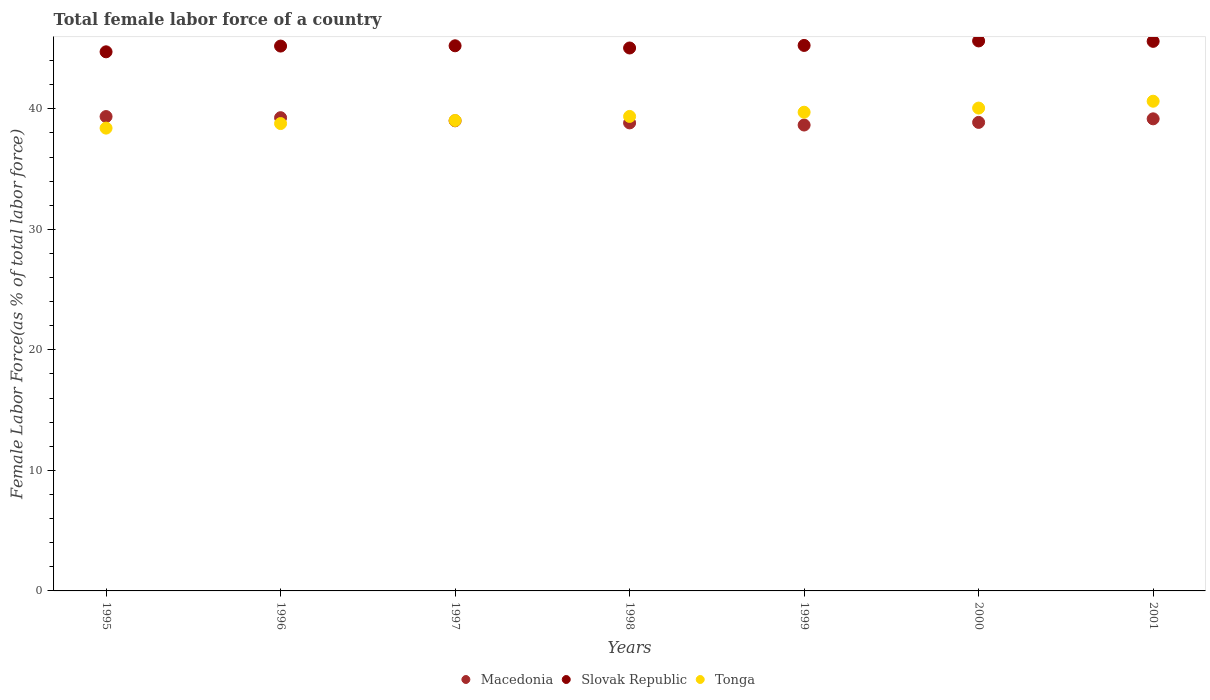How many different coloured dotlines are there?
Your answer should be compact. 3. What is the percentage of female labor force in Slovak Republic in 1997?
Your response must be concise. 45.23. Across all years, what is the maximum percentage of female labor force in Tonga?
Your answer should be very brief. 40.63. Across all years, what is the minimum percentage of female labor force in Slovak Republic?
Your answer should be compact. 44.73. In which year was the percentage of female labor force in Slovak Republic maximum?
Your response must be concise. 2000. What is the total percentage of female labor force in Tonga in the graph?
Your answer should be very brief. 275.99. What is the difference between the percentage of female labor force in Tonga in 1996 and that in 1998?
Make the answer very short. -0.59. What is the difference between the percentage of female labor force in Tonga in 1999 and the percentage of female labor force in Macedonia in 1996?
Your answer should be very brief. 0.45. What is the average percentage of female labor force in Slovak Republic per year?
Ensure brevity in your answer.  45.24. In the year 2001, what is the difference between the percentage of female labor force in Slovak Republic and percentage of female labor force in Tonga?
Your answer should be compact. 4.97. In how many years, is the percentage of female labor force in Tonga greater than 14 %?
Offer a terse response. 7. What is the ratio of the percentage of female labor force in Macedonia in 1995 to that in 1996?
Your answer should be very brief. 1. Is the percentage of female labor force in Tonga in 1996 less than that in 2000?
Your response must be concise. Yes. What is the difference between the highest and the second highest percentage of female labor force in Macedonia?
Make the answer very short. 0.09. What is the difference between the highest and the lowest percentage of female labor force in Slovak Republic?
Your answer should be compact. 0.9. Is it the case that in every year, the sum of the percentage of female labor force in Macedonia and percentage of female labor force in Slovak Republic  is greater than the percentage of female labor force in Tonga?
Ensure brevity in your answer.  Yes. Is the percentage of female labor force in Macedonia strictly greater than the percentage of female labor force in Slovak Republic over the years?
Ensure brevity in your answer.  No. How many dotlines are there?
Your answer should be very brief. 3. How many years are there in the graph?
Keep it short and to the point. 7. What is the difference between two consecutive major ticks on the Y-axis?
Ensure brevity in your answer.  10. Does the graph contain any zero values?
Provide a short and direct response. No. What is the title of the graph?
Give a very brief answer. Total female labor force of a country. Does "China" appear as one of the legend labels in the graph?
Make the answer very short. No. What is the label or title of the X-axis?
Ensure brevity in your answer.  Years. What is the label or title of the Y-axis?
Your response must be concise. Female Labor Force(as % of total labor force). What is the Female Labor Force(as % of total labor force) of Macedonia in 1995?
Provide a short and direct response. 39.36. What is the Female Labor Force(as % of total labor force) in Slovak Republic in 1995?
Your answer should be compact. 44.73. What is the Female Labor Force(as % of total labor force) of Tonga in 1995?
Your answer should be compact. 38.4. What is the Female Labor Force(as % of total labor force) of Macedonia in 1996?
Provide a succinct answer. 39.26. What is the Female Labor Force(as % of total labor force) in Slovak Republic in 1996?
Your response must be concise. 45.21. What is the Female Labor Force(as % of total labor force) in Tonga in 1996?
Ensure brevity in your answer.  38.78. What is the Female Labor Force(as % of total labor force) in Macedonia in 1997?
Offer a terse response. 39.01. What is the Female Labor Force(as % of total labor force) of Slovak Republic in 1997?
Offer a terse response. 45.23. What is the Female Labor Force(as % of total labor force) in Tonga in 1997?
Offer a terse response. 39.03. What is the Female Labor Force(as % of total labor force) in Macedonia in 1998?
Ensure brevity in your answer.  38.83. What is the Female Labor Force(as % of total labor force) in Slovak Republic in 1998?
Offer a very short reply. 45.05. What is the Female Labor Force(as % of total labor force) in Tonga in 1998?
Your answer should be very brief. 39.37. What is the Female Labor Force(as % of total labor force) in Macedonia in 1999?
Your answer should be compact. 38.66. What is the Female Labor Force(as % of total labor force) in Slovak Republic in 1999?
Keep it short and to the point. 45.26. What is the Female Labor Force(as % of total labor force) of Tonga in 1999?
Your answer should be very brief. 39.72. What is the Female Labor Force(as % of total labor force) in Macedonia in 2000?
Make the answer very short. 38.87. What is the Female Labor Force(as % of total labor force) in Slovak Republic in 2000?
Provide a short and direct response. 45.63. What is the Female Labor Force(as % of total labor force) of Tonga in 2000?
Make the answer very short. 40.06. What is the Female Labor Force(as % of total labor force) in Macedonia in 2001?
Offer a very short reply. 39.17. What is the Female Labor Force(as % of total labor force) of Slovak Republic in 2001?
Keep it short and to the point. 45.6. What is the Female Labor Force(as % of total labor force) in Tonga in 2001?
Your response must be concise. 40.63. Across all years, what is the maximum Female Labor Force(as % of total labor force) of Macedonia?
Your response must be concise. 39.36. Across all years, what is the maximum Female Labor Force(as % of total labor force) of Slovak Republic?
Give a very brief answer. 45.63. Across all years, what is the maximum Female Labor Force(as % of total labor force) of Tonga?
Provide a succinct answer. 40.63. Across all years, what is the minimum Female Labor Force(as % of total labor force) in Macedonia?
Ensure brevity in your answer.  38.66. Across all years, what is the minimum Female Labor Force(as % of total labor force) of Slovak Republic?
Make the answer very short. 44.73. Across all years, what is the minimum Female Labor Force(as % of total labor force) in Tonga?
Keep it short and to the point. 38.4. What is the total Female Labor Force(as % of total labor force) in Macedonia in the graph?
Give a very brief answer. 273.17. What is the total Female Labor Force(as % of total labor force) in Slovak Republic in the graph?
Offer a terse response. 316.71. What is the total Female Labor Force(as % of total labor force) in Tonga in the graph?
Offer a very short reply. 275.99. What is the difference between the Female Labor Force(as % of total labor force) of Macedonia in 1995 and that in 1996?
Provide a succinct answer. 0.09. What is the difference between the Female Labor Force(as % of total labor force) of Slovak Republic in 1995 and that in 1996?
Offer a terse response. -0.48. What is the difference between the Female Labor Force(as % of total labor force) of Tonga in 1995 and that in 1996?
Offer a very short reply. -0.38. What is the difference between the Female Labor Force(as % of total labor force) of Macedonia in 1995 and that in 1997?
Ensure brevity in your answer.  0.35. What is the difference between the Female Labor Force(as % of total labor force) of Slovak Republic in 1995 and that in 1997?
Keep it short and to the point. -0.5. What is the difference between the Female Labor Force(as % of total labor force) in Tonga in 1995 and that in 1997?
Your answer should be compact. -0.63. What is the difference between the Female Labor Force(as % of total labor force) of Macedonia in 1995 and that in 1998?
Keep it short and to the point. 0.53. What is the difference between the Female Labor Force(as % of total labor force) in Slovak Republic in 1995 and that in 1998?
Provide a short and direct response. -0.32. What is the difference between the Female Labor Force(as % of total labor force) in Tonga in 1995 and that in 1998?
Offer a terse response. -0.97. What is the difference between the Female Labor Force(as % of total labor force) in Macedonia in 1995 and that in 1999?
Offer a terse response. 0.7. What is the difference between the Female Labor Force(as % of total labor force) in Slovak Republic in 1995 and that in 1999?
Provide a short and direct response. -0.53. What is the difference between the Female Labor Force(as % of total labor force) of Tonga in 1995 and that in 1999?
Your answer should be compact. -1.32. What is the difference between the Female Labor Force(as % of total labor force) in Macedonia in 1995 and that in 2000?
Your answer should be very brief. 0.48. What is the difference between the Female Labor Force(as % of total labor force) of Slovak Republic in 1995 and that in 2000?
Keep it short and to the point. -0.9. What is the difference between the Female Labor Force(as % of total labor force) of Tonga in 1995 and that in 2000?
Keep it short and to the point. -1.66. What is the difference between the Female Labor Force(as % of total labor force) of Macedonia in 1995 and that in 2001?
Keep it short and to the point. 0.19. What is the difference between the Female Labor Force(as % of total labor force) in Slovak Republic in 1995 and that in 2001?
Ensure brevity in your answer.  -0.87. What is the difference between the Female Labor Force(as % of total labor force) in Tonga in 1995 and that in 2001?
Offer a terse response. -2.23. What is the difference between the Female Labor Force(as % of total labor force) in Macedonia in 1996 and that in 1997?
Your response must be concise. 0.26. What is the difference between the Female Labor Force(as % of total labor force) of Slovak Republic in 1996 and that in 1997?
Make the answer very short. -0.02. What is the difference between the Female Labor Force(as % of total labor force) of Tonga in 1996 and that in 1997?
Give a very brief answer. -0.26. What is the difference between the Female Labor Force(as % of total labor force) in Macedonia in 1996 and that in 1998?
Offer a very short reply. 0.43. What is the difference between the Female Labor Force(as % of total labor force) in Slovak Republic in 1996 and that in 1998?
Make the answer very short. 0.16. What is the difference between the Female Labor Force(as % of total labor force) of Tonga in 1996 and that in 1998?
Make the answer very short. -0.59. What is the difference between the Female Labor Force(as % of total labor force) in Macedonia in 1996 and that in 1999?
Give a very brief answer. 0.61. What is the difference between the Female Labor Force(as % of total labor force) in Slovak Republic in 1996 and that in 1999?
Give a very brief answer. -0.05. What is the difference between the Female Labor Force(as % of total labor force) of Tonga in 1996 and that in 1999?
Offer a terse response. -0.94. What is the difference between the Female Labor Force(as % of total labor force) in Macedonia in 1996 and that in 2000?
Provide a short and direct response. 0.39. What is the difference between the Female Labor Force(as % of total labor force) of Slovak Republic in 1996 and that in 2000?
Your answer should be very brief. -0.43. What is the difference between the Female Labor Force(as % of total labor force) in Tonga in 1996 and that in 2000?
Your answer should be compact. -1.28. What is the difference between the Female Labor Force(as % of total labor force) of Macedonia in 1996 and that in 2001?
Provide a succinct answer. 0.09. What is the difference between the Female Labor Force(as % of total labor force) of Slovak Republic in 1996 and that in 2001?
Offer a terse response. -0.39. What is the difference between the Female Labor Force(as % of total labor force) in Tonga in 1996 and that in 2001?
Give a very brief answer. -1.85. What is the difference between the Female Labor Force(as % of total labor force) in Macedonia in 1997 and that in 1998?
Provide a short and direct response. 0.17. What is the difference between the Female Labor Force(as % of total labor force) of Slovak Republic in 1997 and that in 1998?
Offer a terse response. 0.18. What is the difference between the Female Labor Force(as % of total labor force) in Tonga in 1997 and that in 1998?
Offer a terse response. -0.34. What is the difference between the Female Labor Force(as % of total labor force) of Macedonia in 1997 and that in 1999?
Provide a succinct answer. 0.35. What is the difference between the Female Labor Force(as % of total labor force) of Slovak Republic in 1997 and that in 1999?
Give a very brief answer. -0.03. What is the difference between the Female Labor Force(as % of total labor force) of Tonga in 1997 and that in 1999?
Keep it short and to the point. -0.69. What is the difference between the Female Labor Force(as % of total labor force) in Macedonia in 1997 and that in 2000?
Provide a succinct answer. 0.13. What is the difference between the Female Labor Force(as % of total labor force) in Slovak Republic in 1997 and that in 2000?
Offer a terse response. -0.4. What is the difference between the Female Labor Force(as % of total labor force) of Tonga in 1997 and that in 2000?
Your answer should be very brief. -1.03. What is the difference between the Female Labor Force(as % of total labor force) of Macedonia in 1997 and that in 2001?
Provide a succinct answer. -0.16. What is the difference between the Female Labor Force(as % of total labor force) in Slovak Republic in 1997 and that in 2001?
Provide a short and direct response. -0.37. What is the difference between the Female Labor Force(as % of total labor force) of Tonga in 1997 and that in 2001?
Your answer should be very brief. -1.6. What is the difference between the Female Labor Force(as % of total labor force) in Macedonia in 1998 and that in 1999?
Ensure brevity in your answer.  0.18. What is the difference between the Female Labor Force(as % of total labor force) of Slovak Republic in 1998 and that in 1999?
Your answer should be compact. -0.21. What is the difference between the Female Labor Force(as % of total labor force) of Tonga in 1998 and that in 1999?
Your response must be concise. -0.35. What is the difference between the Female Labor Force(as % of total labor force) in Macedonia in 1998 and that in 2000?
Your response must be concise. -0.04. What is the difference between the Female Labor Force(as % of total labor force) of Slovak Republic in 1998 and that in 2000?
Your answer should be compact. -0.59. What is the difference between the Female Labor Force(as % of total labor force) in Tonga in 1998 and that in 2000?
Make the answer very short. -0.69. What is the difference between the Female Labor Force(as % of total labor force) of Macedonia in 1998 and that in 2001?
Your answer should be very brief. -0.34. What is the difference between the Female Labor Force(as % of total labor force) in Slovak Republic in 1998 and that in 2001?
Provide a short and direct response. -0.55. What is the difference between the Female Labor Force(as % of total labor force) of Tonga in 1998 and that in 2001?
Give a very brief answer. -1.26. What is the difference between the Female Labor Force(as % of total labor force) in Macedonia in 1999 and that in 2000?
Provide a succinct answer. -0.22. What is the difference between the Female Labor Force(as % of total labor force) in Slovak Republic in 1999 and that in 2000?
Provide a short and direct response. -0.37. What is the difference between the Female Labor Force(as % of total labor force) of Tonga in 1999 and that in 2000?
Make the answer very short. -0.34. What is the difference between the Female Labor Force(as % of total labor force) in Macedonia in 1999 and that in 2001?
Your response must be concise. -0.51. What is the difference between the Female Labor Force(as % of total labor force) in Slovak Republic in 1999 and that in 2001?
Your response must be concise. -0.34. What is the difference between the Female Labor Force(as % of total labor force) in Tonga in 1999 and that in 2001?
Your answer should be very brief. -0.91. What is the difference between the Female Labor Force(as % of total labor force) in Macedonia in 2000 and that in 2001?
Your answer should be very brief. -0.3. What is the difference between the Female Labor Force(as % of total labor force) of Slovak Republic in 2000 and that in 2001?
Offer a terse response. 0.03. What is the difference between the Female Labor Force(as % of total labor force) in Tonga in 2000 and that in 2001?
Offer a terse response. -0.57. What is the difference between the Female Labor Force(as % of total labor force) in Macedonia in 1995 and the Female Labor Force(as % of total labor force) in Slovak Republic in 1996?
Offer a very short reply. -5.85. What is the difference between the Female Labor Force(as % of total labor force) of Macedonia in 1995 and the Female Labor Force(as % of total labor force) of Tonga in 1996?
Offer a terse response. 0.58. What is the difference between the Female Labor Force(as % of total labor force) in Slovak Republic in 1995 and the Female Labor Force(as % of total labor force) in Tonga in 1996?
Your answer should be very brief. 5.95. What is the difference between the Female Labor Force(as % of total labor force) in Macedonia in 1995 and the Female Labor Force(as % of total labor force) in Slovak Republic in 1997?
Provide a succinct answer. -5.87. What is the difference between the Female Labor Force(as % of total labor force) of Macedonia in 1995 and the Female Labor Force(as % of total labor force) of Tonga in 1997?
Provide a short and direct response. 0.32. What is the difference between the Female Labor Force(as % of total labor force) of Slovak Republic in 1995 and the Female Labor Force(as % of total labor force) of Tonga in 1997?
Ensure brevity in your answer.  5.7. What is the difference between the Female Labor Force(as % of total labor force) in Macedonia in 1995 and the Female Labor Force(as % of total labor force) in Slovak Republic in 1998?
Your response must be concise. -5.69. What is the difference between the Female Labor Force(as % of total labor force) of Macedonia in 1995 and the Female Labor Force(as % of total labor force) of Tonga in 1998?
Offer a very short reply. -0.01. What is the difference between the Female Labor Force(as % of total labor force) of Slovak Republic in 1995 and the Female Labor Force(as % of total labor force) of Tonga in 1998?
Keep it short and to the point. 5.36. What is the difference between the Female Labor Force(as % of total labor force) in Macedonia in 1995 and the Female Labor Force(as % of total labor force) in Slovak Republic in 1999?
Make the answer very short. -5.9. What is the difference between the Female Labor Force(as % of total labor force) of Macedonia in 1995 and the Female Labor Force(as % of total labor force) of Tonga in 1999?
Provide a short and direct response. -0.36. What is the difference between the Female Labor Force(as % of total labor force) of Slovak Republic in 1995 and the Female Labor Force(as % of total labor force) of Tonga in 1999?
Your answer should be compact. 5.01. What is the difference between the Female Labor Force(as % of total labor force) in Macedonia in 1995 and the Female Labor Force(as % of total labor force) in Slovak Republic in 2000?
Offer a very short reply. -6.28. What is the difference between the Female Labor Force(as % of total labor force) of Macedonia in 1995 and the Female Labor Force(as % of total labor force) of Tonga in 2000?
Make the answer very short. -0.7. What is the difference between the Female Labor Force(as % of total labor force) in Slovak Republic in 1995 and the Female Labor Force(as % of total labor force) in Tonga in 2000?
Your response must be concise. 4.67. What is the difference between the Female Labor Force(as % of total labor force) in Macedonia in 1995 and the Female Labor Force(as % of total labor force) in Slovak Republic in 2001?
Make the answer very short. -6.24. What is the difference between the Female Labor Force(as % of total labor force) of Macedonia in 1995 and the Female Labor Force(as % of total labor force) of Tonga in 2001?
Provide a short and direct response. -1.27. What is the difference between the Female Labor Force(as % of total labor force) in Slovak Republic in 1995 and the Female Labor Force(as % of total labor force) in Tonga in 2001?
Your answer should be very brief. 4.1. What is the difference between the Female Labor Force(as % of total labor force) of Macedonia in 1996 and the Female Labor Force(as % of total labor force) of Slovak Republic in 1997?
Your answer should be very brief. -5.97. What is the difference between the Female Labor Force(as % of total labor force) in Macedonia in 1996 and the Female Labor Force(as % of total labor force) in Tonga in 1997?
Provide a short and direct response. 0.23. What is the difference between the Female Labor Force(as % of total labor force) in Slovak Republic in 1996 and the Female Labor Force(as % of total labor force) in Tonga in 1997?
Your answer should be compact. 6.17. What is the difference between the Female Labor Force(as % of total labor force) of Macedonia in 1996 and the Female Labor Force(as % of total labor force) of Slovak Republic in 1998?
Offer a very short reply. -5.78. What is the difference between the Female Labor Force(as % of total labor force) in Macedonia in 1996 and the Female Labor Force(as % of total labor force) in Tonga in 1998?
Give a very brief answer. -0.1. What is the difference between the Female Labor Force(as % of total labor force) of Slovak Republic in 1996 and the Female Labor Force(as % of total labor force) of Tonga in 1998?
Your answer should be compact. 5.84. What is the difference between the Female Labor Force(as % of total labor force) in Macedonia in 1996 and the Female Labor Force(as % of total labor force) in Slovak Republic in 1999?
Provide a succinct answer. -6. What is the difference between the Female Labor Force(as % of total labor force) of Macedonia in 1996 and the Female Labor Force(as % of total labor force) of Tonga in 1999?
Offer a terse response. -0.45. What is the difference between the Female Labor Force(as % of total labor force) of Slovak Republic in 1996 and the Female Labor Force(as % of total labor force) of Tonga in 1999?
Give a very brief answer. 5.49. What is the difference between the Female Labor Force(as % of total labor force) of Macedonia in 1996 and the Female Labor Force(as % of total labor force) of Slovak Republic in 2000?
Offer a very short reply. -6.37. What is the difference between the Female Labor Force(as % of total labor force) in Macedonia in 1996 and the Female Labor Force(as % of total labor force) in Tonga in 2000?
Your answer should be very brief. -0.8. What is the difference between the Female Labor Force(as % of total labor force) of Slovak Republic in 1996 and the Female Labor Force(as % of total labor force) of Tonga in 2000?
Keep it short and to the point. 5.15. What is the difference between the Female Labor Force(as % of total labor force) in Macedonia in 1996 and the Female Labor Force(as % of total labor force) in Slovak Republic in 2001?
Keep it short and to the point. -6.33. What is the difference between the Female Labor Force(as % of total labor force) in Macedonia in 1996 and the Female Labor Force(as % of total labor force) in Tonga in 2001?
Keep it short and to the point. -1.37. What is the difference between the Female Labor Force(as % of total labor force) of Slovak Republic in 1996 and the Female Labor Force(as % of total labor force) of Tonga in 2001?
Keep it short and to the point. 4.58. What is the difference between the Female Labor Force(as % of total labor force) of Macedonia in 1997 and the Female Labor Force(as % of total labor force) of Slovak Republic in 1998?
Offer a very short reply. -6.04. What is the difference between the Female Labor Force(as % of total labor force) of Macedonia in 1997 and the Female Labor Force(as % of total labor force) of Tonga in 1998?
Keep it short and to the point. -0.36. What is the difference between the Female Labor Force(as % of total labor force) in Slovak Republic in 1997 and the Female Labor Force(as % of total labor force) in Tonga in 1998?
Your response must be concise. 5.86. What is the difference between the Female Labor Force(as % of total labor force) in Macedonia in 1997 and the Female Labor Force(as % of total labor force) in Slovak Republic in 1999?
Provide a short and direct response. -6.25. What is the difference between the Female Labor Force(as % of total labor force) in Macedonia in 1997 and the Female Labor Force(as % of total labor force) in Tonga in 1999?
Your answer should be very brief. -0.71. What is the difference between the Female Labor Force(as % of total labor force) in Slovak Republic in 1997 and the Female Labor Force(as % of total labor force) in Tonga in 1999?
Your answer should be very brief. 5.51. What is the difference between the Female Labor Force(as % of total labor force) of Macedonia in 1997 and the Female Labor Force(as % of total labor force) of Slovak Republic in 2000?
Keep it short and to the point. -6.63. What is the difference between the Female Labor Force(as % of total labor force) in Macedonia in 1997 and the Female Labor Force(as % of total labor force) in Tonga in 2000?
Give a very brief answer. -1.06. What is the difference between the Female Labor Force(as % of total labor force) of Slovak Republic in 1997 and the Female Labor Force(as % of total labor force) of Tonga in 2000?
Your answer should be compact. 5.17. What is the difference between the Female Labor Force(as % of total labor force) of Macedonia in 1997 and the Female Labor Force(as % of total labor force) of Slovak Republic in 2001?
Your response must be concise. -6.59. What is the difference between the Female Labor Force(as % of total labor force) of Macedonia in 1997 and the Female Labor Force(as % of total labor force) of Tonga in 2001?
Offer a terse response. -1.62. What is the difference between the Female Labor Force(as % of total labor force) in Slovak Republic in 1997 and the Female Labor Force(as % of total labor force) in Tonga in 2001?
Provide a succinct answer. 4.6. What is the difference between the Female Labor Force(as % of total labor force) in Macedonia in 1998 and the Female Labor Force(as % of total labor force) in Slovak Republic in 1999?
Ensure brevity in your answer.  -6.43. What is the difference between the Female Labor Force(as % of total labor force) in Macedonia in 1998 and the Female Labor Force(as % of total labor force) in Tonga in 1999?
Keep it short and to the point. -0.89. What is the difference between the Female Labor Force(as % of total labor force) in Slovak Republic in 1998 and the Female Labor Force(as % of total labor force) in Tonga in 1999?
Your answer should be very brief. 5.33. What is the difference between the Female Labor Force(as % of total labor force) of Macedonia in 1998 and the Female Labor Force(as % of total labor force) of Slovak Republic in 2000?
Ensure brevity in your answer.  -6.8. What is the difference between the Female Labor Force(as % of total labor force) in Macedonia in 1998 and the Female Labor Force(as % of total labor force) in Tonga in 2000?
Ensure brevity in your answer.  -1.23. What is the difference between the Female Labor Force(as % of total labor force) of Slovak Republic in 1998 and the Female Labor Force(as % of total labor force) of Tonga in 2000?
Your answer should be compact. 4.99. What is the difference between the Female Labor Force(as % of total labor force) of Macedonia in 1998 and the Female Labor Force(as % of total labor force) of Slovak Republic in 2001?
Make the answer very short. -6.77. What is the difference between the Female Labor Force(as % of total labor force) of Macedonia in 1998 and the Female Labor Force(as % of total labor force) of Tonga in 2001?
Provide a short and direct response. -1.8. What is the difference between the Female Labor Force(as % of total labor force) of Slovak Republic in 1998 and the Female Labor Force(as % of total labor force) of Tonga in 2001?
Keep it short and to the point. 4.42. What is the difference between the Female Labor Force(as % of total labor force) of Macedonia in 1999 and the Female Labor Force(as % of total labor force) of Slovak Republic in 2000?
Provide a short and direct response. -6.98. What is the difference between the Female Labor Force(as % of total labor force) in Macedonia in 1999 and the Female Labor Force(as % of total labor force) in Tonga in 2000?
Make the answer very short. -1.41. What is the difference between the Female Labor Force(as % of total labor force) of Slovak Republic in 1999 and the Female Labor Force(as % of total labor force) of Tonga in 2000?
Make the answer very short. 5.2. What is the difference between the Female Labor Force(as % of total labor force) in Macedonia in 1999 and the Female Labor Force(as % of total labor force) in Slovak Republic in 2001?
Your answer should be compact. -6.94. What is the difference between the Female Labor Force(as % of total labor force) in Macedonia in 1999 and the Female Labor Force(as % of total labor force) in Tonga in 2001?
Your answer should be compact. -1.98. What is the difference between the Female Labor Force(as % of total labor force) of Slovak Republic in 1999 and the Female Labor Force(as % of total labor force) of Tonga in 2001?
Make the answer very short. 4.63. What is the difference between the Female Labor Force(as % of total labor force) in Macedonia in 2000 and the Female Labor Force(as % of total labor force) in Slovak Republic in 2001?
Ensure brevity in your answer.  -6.72. What is the difference between the Female Labor Force(as % of total labor force) in Macedonia in 2000 and the Female Labor Force(as % of total labor force) in Tonga in 2001?
Make the answer very short. -1.76. What is the difference between the Female Labor Force(as % of total labor force) of Slovak Republic in 2000 and the Female Labor Force(as % of total labor force) of Tonga in 2001?
Ensure brevity in your answer.  5. What is the average Female Labor Force(as % of total labor force) in Macedonia per year?
Your response must be concise. 39.02. What is the average Female Labor Force(as % of total labor force) of Slovak Republic per year?
Give a very brief answer. 45.24. What is the average Female Labor Force(as % of total labor force) of Tonga per year?
Your answer should be very brief. 39.43. In the year 1995, what is the difference between the Female Labor Force(as % of total labor force) in Macedonia and Female Labor Force(as % of total labor force) in Slovak Republic?
Your answer should be very brief. -5.37. In the year 1995, what is the difference between the Female Labor Force(as % of total labor force) in Macedonia and Female Labor Force(as % of total labor force) in Tonga?
Provide a short and direct response. 0.96. In the year 1995, what is the difference between the Female Labor Force(as % of total labor force) of Slovak Republic and Female Labor Force(as % of total labor force) of Tonga?
Offer a terse response. 6.33. In the year 1996, what is the difference between the Female Labor Force(as % of total labor force) of Macedonia and Female Labor Force(as % of total labor force) of Slovak Republic?
Your answer should be very brief. -5.94. In the year 1996, what is the difference between the Female Labor Force(as % of total labor force) of Macedonia and Female Labor Force(as % of total labor force) of Tonga?
Your answer should be very brief. 0.49. In the year 1996, what is the difference between the Female Labor Force(as % of total labor force) in Slovak Republic and Female Labor Force(as % of total labor force) in Tonga?
Offer a very short reply. 6.43. In the year 1997, what is the difference between the Female Labor Force(as % of total labor force) in Macedonia and Female Labor Force(as % of total labor force) in Slovak Republic?
Your answer should be compact. -6.23. In the year 1997, what is the difference between the Female Labor Force(as % of total labor force) in Macedonia and Female Labor Force(as % of total labor force) in Tonga?
Provide a short and direct response. -0.03. In the year 1997, what is the difference between the Female Labor Force(as % of total labor force) in Slovak Republic and Female Labor Force(as % of total labor force) in Tonga?
Provide a succinct answer. 6.2. In the year 1998, what is the difference between the Female Labor Force(as % of total labor force) of Macedonia and Female Labor Force(as % of total labor force) of Slovak Republic?
Provide a succinct answer. -6.22. In the year 1998, what is the difference between the Female Labor Force(as % of total labor force) of Macedonia and Female Labor Force(as % of total labor force) of Tonga?
Keep it short and to the point. -0.54. In the year 1998, what is the difference between the Female Labor Force(as % of total labor force) of Slovak Republic and Female Labor Force(as % of total labor force) of Tonga?
Provide a short and direct response. 5.68. In the year 1999, what is the difference between the Female Labor Force(as % of total labor force) of Macedonia and Female Labor Force(as % of total labor force) of Slovak Republic?
Your answer should be very brief. -6.6. In the year 1999, what is the difference between the Female Labor Force(as % of total labor force) in Macedonia and Female Labor Force(as % of total labor force) in Tonga?
Make the answer very short. -1.06. In the year 1999, what is the difference between the Female Labor Force(as % of total labor force) in Slovak Republic and Female Labor Force(as % of total labor force) in Tonga?
Offer a terse response. 5.54. In the year 2000, what is the difference between the Female Labor Force(as % of total labor force) of Macedonia and Female Labor Force(as % of total labor force) of Slovak Republic?
Your answer should be very brief. -6.76. In the year 2000, what is the difference between the Female Labor Force(as % of total labor force) in Macedonia and Female Labor Force(as % of total labor force) in Tonga?
Keep it short and to the point. -1.19. In the year 2000, what is the difference between the Female Labor Force(as % of total labor force) of Slovak Republic and Female Labor Force(as % of total labor force) of Tonga?
Your response must be concise. 5.57. In the year 2001, what is the difference between the Female Labor Force(as % of total labor force) in Macedonia and Female Labor Force(as % of total labor force) in Slovak Republic?
Give a very brief answer. -6.43. In the year 2001, what is the difference between the Female Labor Force(as % of total labor force) of Macedonia and Female Labor Force(as % of total labor force) of Tonga?
Your answer should be compact. -1.46. In the year 2001, what is the difference between the Female Labor Force(as % of total labor force) in Slovak Republic and Female Labor Force(as % of total labor force) in Tonga?
Your answer should be compact. 4.97. What is the ratio of the Female Labor Force(as % of total labor force) in Macedonia in 1995 to that in 1996?
Give a very brief answer. 1. What is the ratio of the Female Labor Force(as % of total labor force) of Tonga in 1995 to that in 1996?
Provide a short and direct response. 0.99. What is the ratio of the Female Labor Force(as % of total labor force) of Slovak Republic in 1995 to that in 1997?
Offer a very short reply. 0.99. What is the ratio of the Female Labor Force(as % of total labor force) in Tonga in 1995 to that in 1997?
Your answer should be very brief. 0.98. What is the ratio of the Female Labor Force(as % of total labor force) of Macedonia in 1995 to that in 1998?
Your response must be concise. 1.01. What is the ratio of the Female Labor Force(as % of total labor force) of Tonga in 1995 to that in 1998?
Make the answer very short. 0.98. What is the ratio of the Female Labor Force(as % of total labor force) of Macedonia in 1995 to that in 1999?
Offer a terse response. 1.02. What is the ratio of the Female Labor Force(as % of total labor force) of Slovak Republic in 1995 to that in 1999?
Give a very brief answer. 0.99. What is the ratio of the Female Labor Force(as % of total labor force) in Tonga in 1995 to that in 1999?
Keep it short and to the point. 0.97. What is the ratio of the Female Labor Force(as % of total labor force) of Macedonia in 1995 to that in 2000?
Give a very brief answer. 1.01. What is the ratio of the Female Labor Force(as % of total labor force) of Slovak Republic in 1995 to that in 2000?
Provide a short and direct response. 0.98. What is the ratio of the Female Labor Force(as % of total labor force) of Tonga in 1995 to that in 2000?
Make the answer very short. 0.96. What is the ratio of the Female Labor Force(as % of total labor force) of Tonga in 1995 to that in 2001?
Provide a succinct answer. 0.95. What is the ratio of the Female Labor Force(as % of total labor force) in Macedonia in 1996 to that in 1997?
Offer a very short reply. 1.01. What is the ratio of the Female Labor Force(as % of total labor force) of Tonga in 1996 to that in 1997?
Make the answer very short. 0.99. What is the ratio of the Female Labor Force(as % of total labor force) of Macedonia in 1996 to that in 1998?
Make the answer very short. 1.01. What is the ratio of the Female Labor Force(as % of total labor force) in Tonga in 1996 to that in 1998?
Your answer should be compact. 0.98. What is the ratio of the Female Labor Force(as % of total labor force) in Macedonia in 1996 to that in 1999?
Your response must be concise. 1.02. What is the ratio of the Female Labor Force(as % of total labor force) of Slovak Republic in 1996 to that in 1999?
Your response must be concise. 1. What is the ratio of the Female Labor Force(as % of total labor force) in Tonga in 1996 to that in 1999?
Ensure brevity in your answer.  0.98. What is the ratio of the Female Labor Force(as % of total labor force) in Macedonia in 1996 to that in 2001?
Offer a terse response. 1. What is the ratio of the Female Labor Force(as % of total labor force) in Slovak Republic in 1996 to that in 2001?
Keep it short and to the point. 0.99. What is the ratio of the Female Labor Force(as % of total labor force) of Tonga in 1996 to that in 2001?
Ensure brevity in your answer.  0.95. What is the ratio of the Female Labor Force(as % of total labor force) of Tonga in 1997 to that in 1998?
Keep it short and to the point. 0.99. What is the ratio of the Female Labor Force(as % of total labor force) of Macedonia in 1997 to that in 1999?
Provide a short and direct response. 1.01. What is the ratio of the Female Labor Force(as % of total labor force) in Slovak Republic in 1997 to that in 1999?
Ensure brevity in your answer.  1. What is the ratio of the Female Labor Force(as % of total labor force) in Tonga in 1997 to that in 1999?
Offer a terse response. 0.98. What is the ratio of the Female Labor Force(as % of total labor force) in Macedonia in 1997 to that in 2000?
Your response must be concise. 1. What is the ratio of the Female Labor Force(as % of total labor force) of Tonga in 1997 to that in 2000?
Provide a succinct answer. 0.97. What is the ratio of the Female Labor Force(as % of total labor force) of Slovak Republic in 1997 to that in 2001?
Your response must be concise. 0.99. What is the ratio of the Female Labor Force(as % of total labor force) in Tonga in 1997 to that in 2001?
Give a very brief answer. 0.96. What is the ratio of the Female Labor Force(as % of total labor force) in Macedonia in 1998 to that in 1999?
Give a very brief answer. 1. What is the ratio of the Female Labor Force(as % of total labor force) of Tonga in 1998 to that in 1999?
Give a very brief answer. 0.99. What is the ratio of the Female Labor Force(as % of total labor force) in Macedonia in 1998 to that in 2000?
Your response must be concise. 1. What is the ratio of the Female Labor Force(as % of total labor force) of Slovak Republic in 1998 to that in 2000?
Your answer should be very brief. 0.99. What is the ratio of the Female Labor Force(as % of total labor force) in Tonga in 1998 to that in 2000?
Offer a very short reply. 0.98. What is the ratio of the Female Labor Force(as % of total labor force) in Slovak Republic in 1998 to that in 2001?
Give a very brief answer. 0.99. What is the ratio of the Female Labor Force(as % of total labor force) of Tonga in 1998 to that in 2001?
Your response must be concise. 0.97. What is the ratio of the Female Labor Force(as % of total labor force) in Macedonia in 1999 to that in 2000?
Provide a short and direct response. 0.99. What is the ratio of the Female Labor Force(as % of total labor force) in Macedonia in 1999 to that in 2001?
Make the answer very short. 0.99. What is the ratio of the Female Labor Force(as % of total labor force) of Tonga in 1999 to that in 2001?
Offer a very short reply. 0.98. What is the ratio of the Female Labor Force(as % of total labor force) of Slovak Republic in 2000 to that in 2001?
Offer a very short reply. 1. What is the ratio of the Female Labor Force(as % of total labor force) in Tonga in 2000 to that in 2001?
Make the answer very short. 0.99. What is the difference between the highest and the second highest Female Labor Force(as % of total labor force) in Macedonia?
Your response must be concise. 0.09. What is the difference between the highest and the second highest Female Labor Force(as % of total labor force) in Slovak Republic?
Make the answer very short. 0.03. What is the difference between the highest and the second highest Female Labor Force(as % of total labor force) of Tonga?
Ensure brevity in your answer.  0.57. What is the difference between the highest and the lowest Female Labor Force(as % of total labor force) of Macedonia?
Your response must be concise. 0.7. What is the difference between the highest and the lowest Female Labor Force(as % of total labor force) in Slovak Republic?
Make the answer very short. 0.9. What is the difference between the highest and the lowest Female Labor Force(as % of total labor force) in Tonga?
Your answer should be very brief. 2.23. 